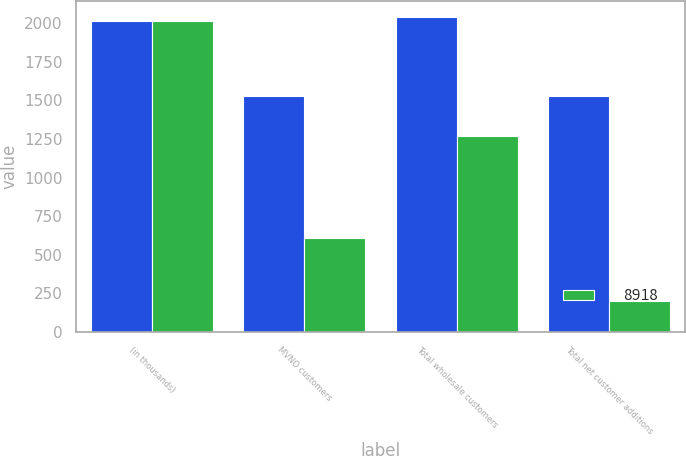<chart> <loc_0><loc_0><loc_500><loc_500><stacked_bar_chart><ecel><fcel>(in thousands)<fcel>MVNO customers<fcel>Total wholesale customers<fcel>Total net customer additions<nl><fcel>nan<fcel>2013<fcel>1531<fcel>2043<fcel>1531<nl><fcel>8918<fcel>2012<fcel>610<fcel>1270<fcel>203<nl></chart> 